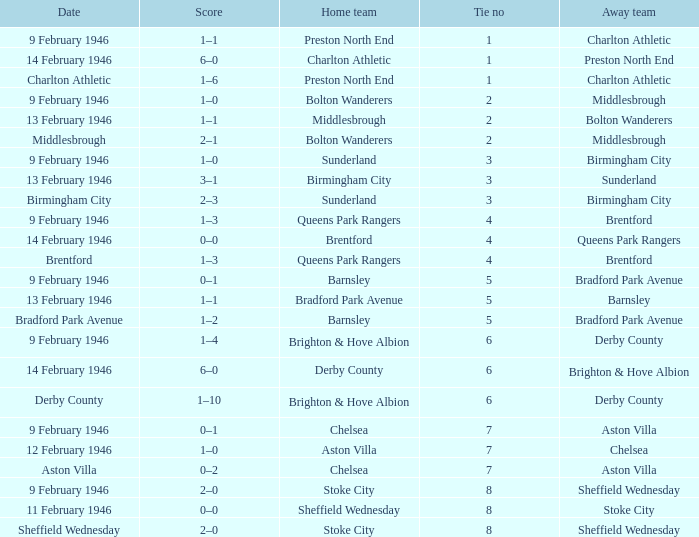What was the Tie no when then home team was Stoke City for the game played on 9 February 1946? 8.0. 